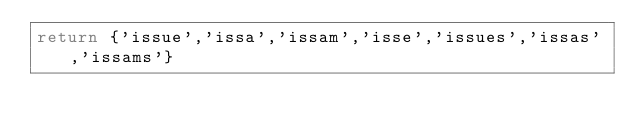Convert code to text. <code><loc_0><loc_0><loc_500><loc_500><_Lua_>return {'issue','issa','issam','isse','issues','issas','issams'}</code> 